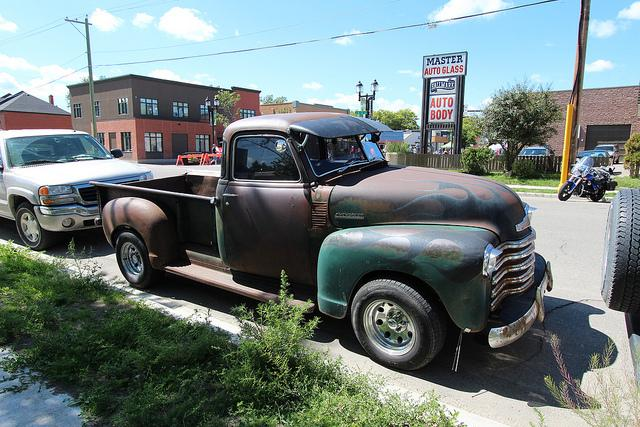What sort of business are the autos in all likelihood closest to?

Choices:
A) gas station
B) restaurant
C) auto repair
D) dealership auto repair 